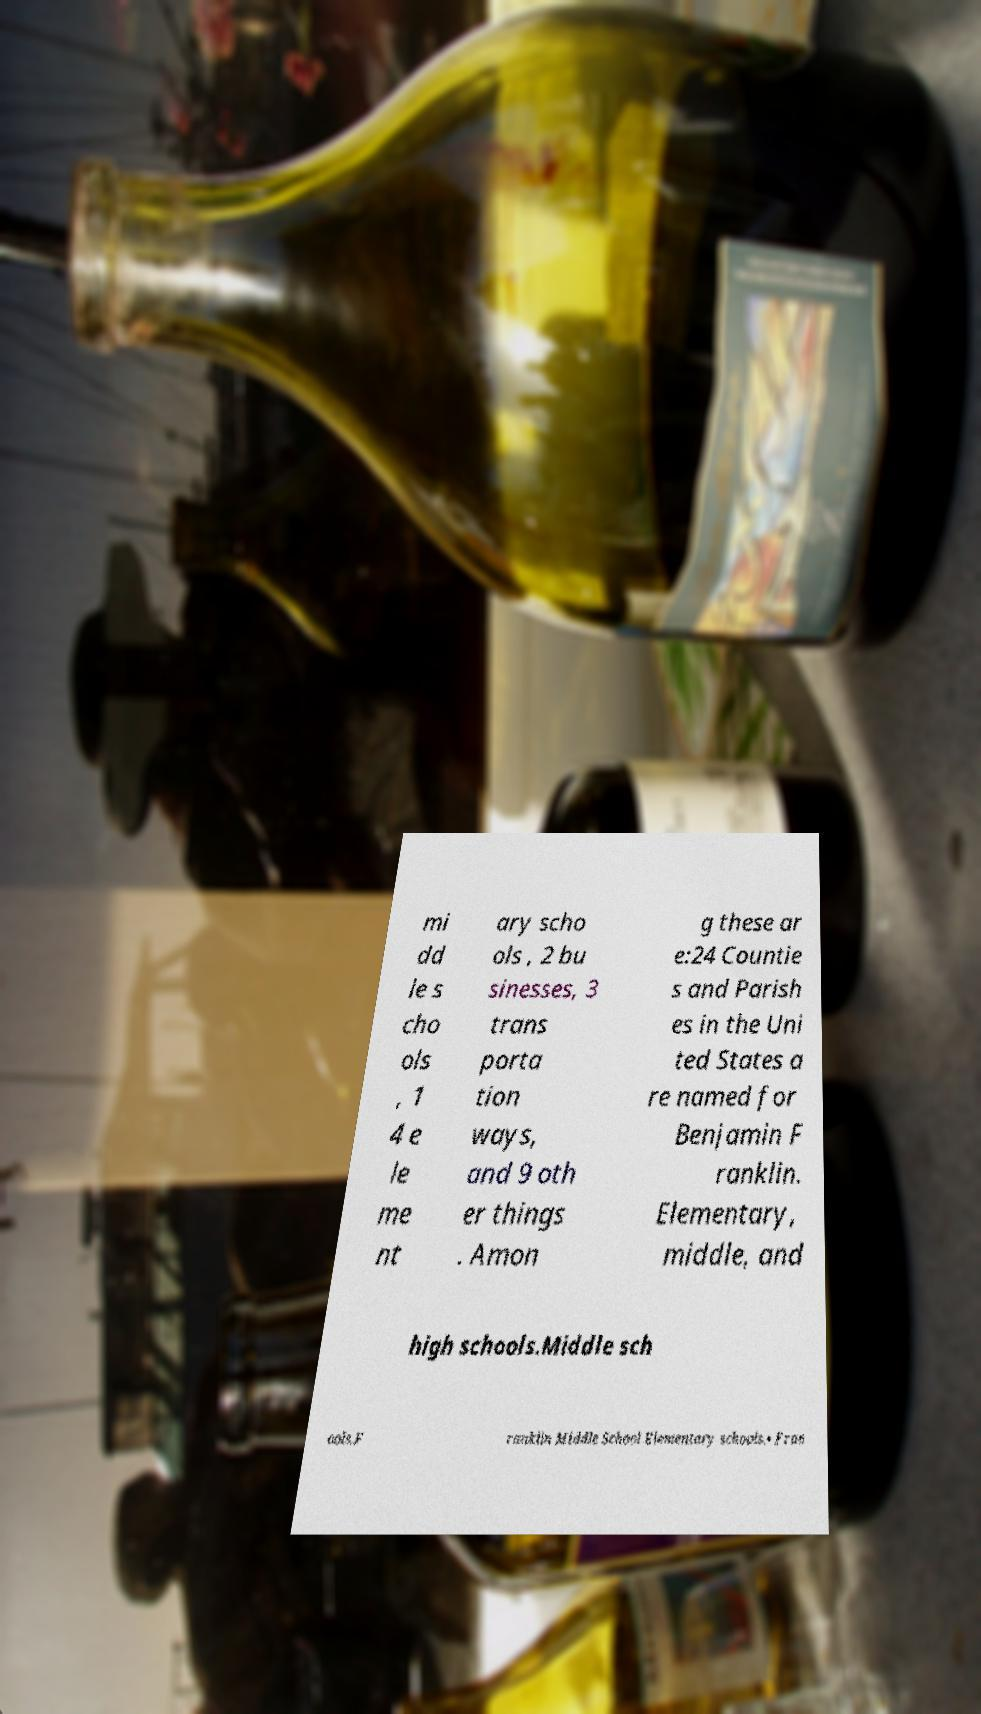Could you assist in decoding the text presented in this image and type it out clearly? mi dd le s cho ols , 1 4 e le me nt ary scho ols , 2 bu sinesses, 3 trans porta tion ways, and 9 oth er things . Amon g these ar e:24 Countie s and Parish es in the Uni ted States a re named for Benjamin F ranklin. Elementary, middle, and high schools.Middle sch ools.F ranklin Middle School Elementary schools.• Fran 